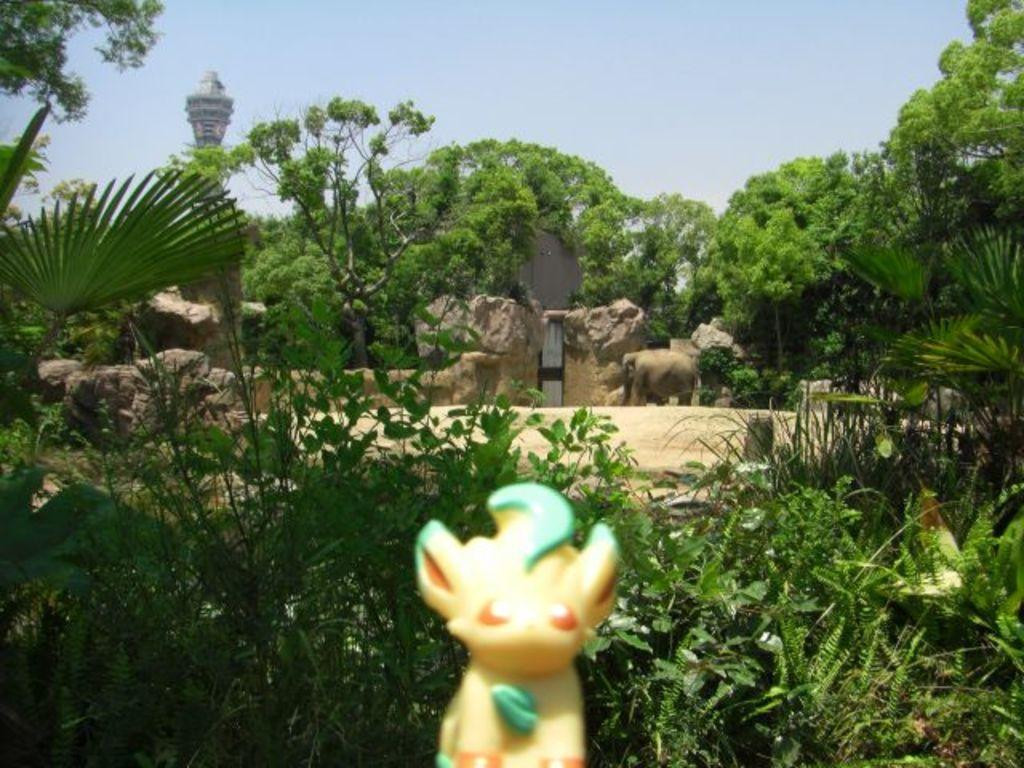What object can be seen in the image that is typically used for play? There is a toy in the image. What type of vegetation is present in the image? There are plants and trees in the image. What animal is on the ground in the image? There is an elephant on the ground in the image. What architectural feature is present in the image? There is a gate to the wall in the image. What tall structure can be seen in the image? There is a tower in the image. What part of the natural environment is visible in the background of the image? The sky is visible in the background of the image. How many girls are playing with the paste in the image? There are no girls or paste present in the image. What type of thunder can be heard in the image? There is no sound, including thunder, present in the image. 